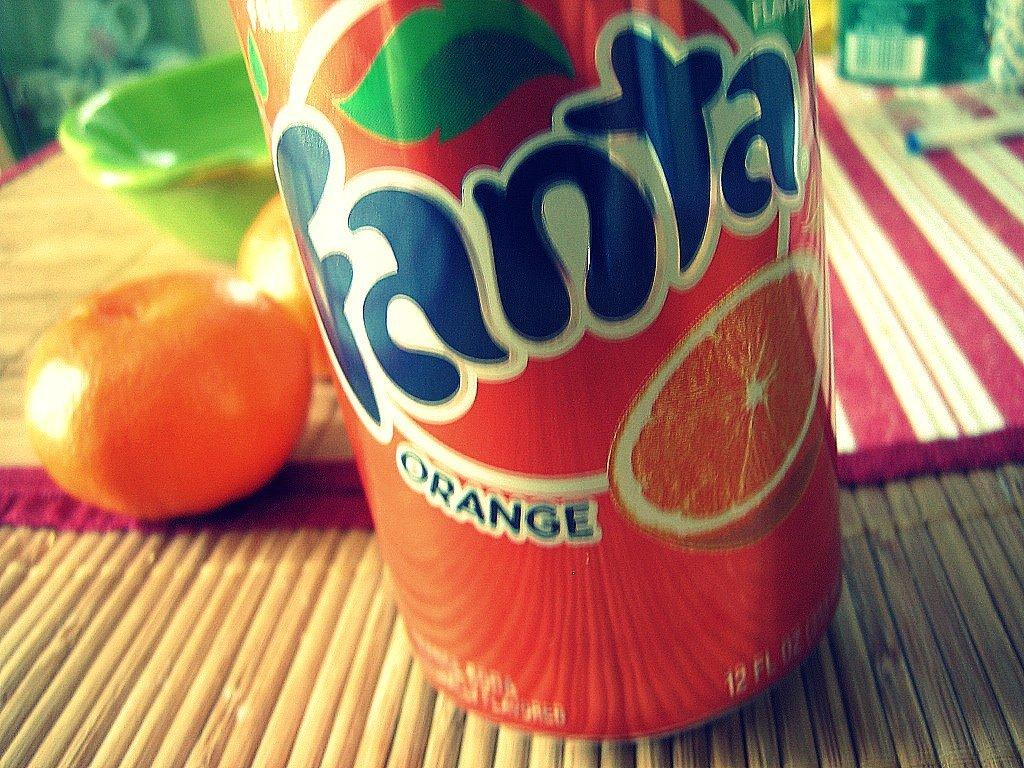What type of drink is visible in the image? The type of drink is not specified in the facts. What fruit is present in the image? There is an orange in the image. What other items can be seen in the image besides the drink and orange? There are other unspecified items in the image. Where is the crib located in the image? There is no crib present in the image. What type of match is being used to light the orange in the image? There is no match or lighting of the orange depicted in the image. 